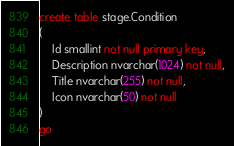<code> <loc_0><loc_0><loc_500><loc_500><_SQL_>create table stage.Condition
(
	Id smallint not null primary key,
	Description nvarchar(1024) not null,
	Title nvarchar(255) not null,
	Icon nvarchar(50) not null
)
go

</code> 